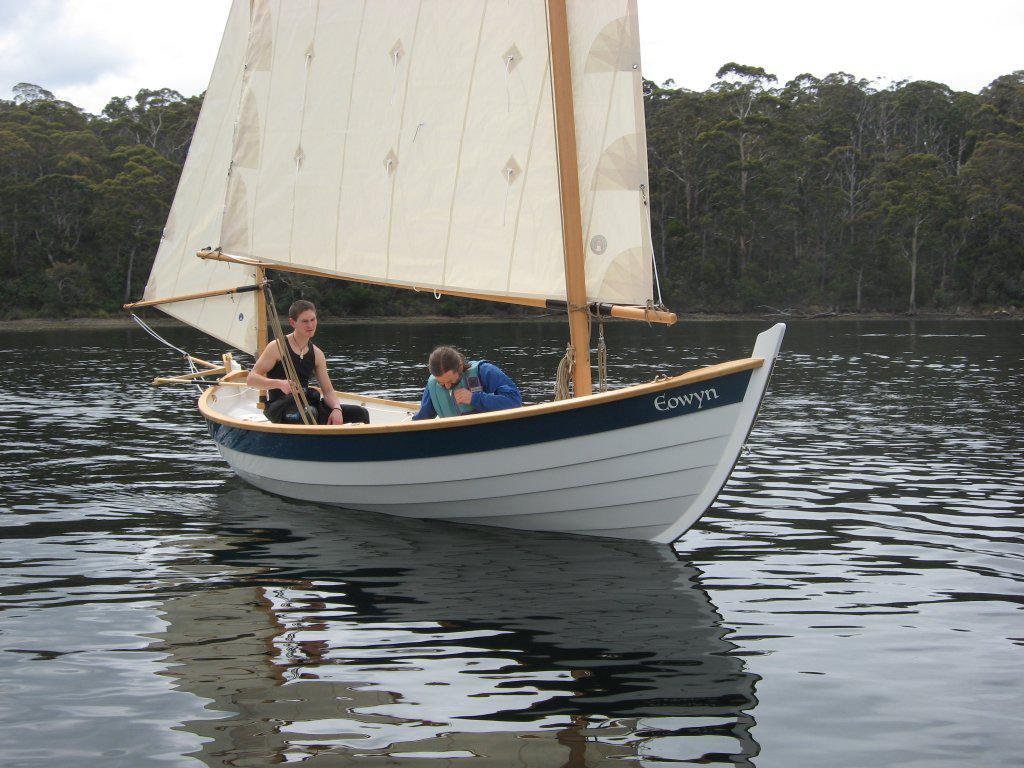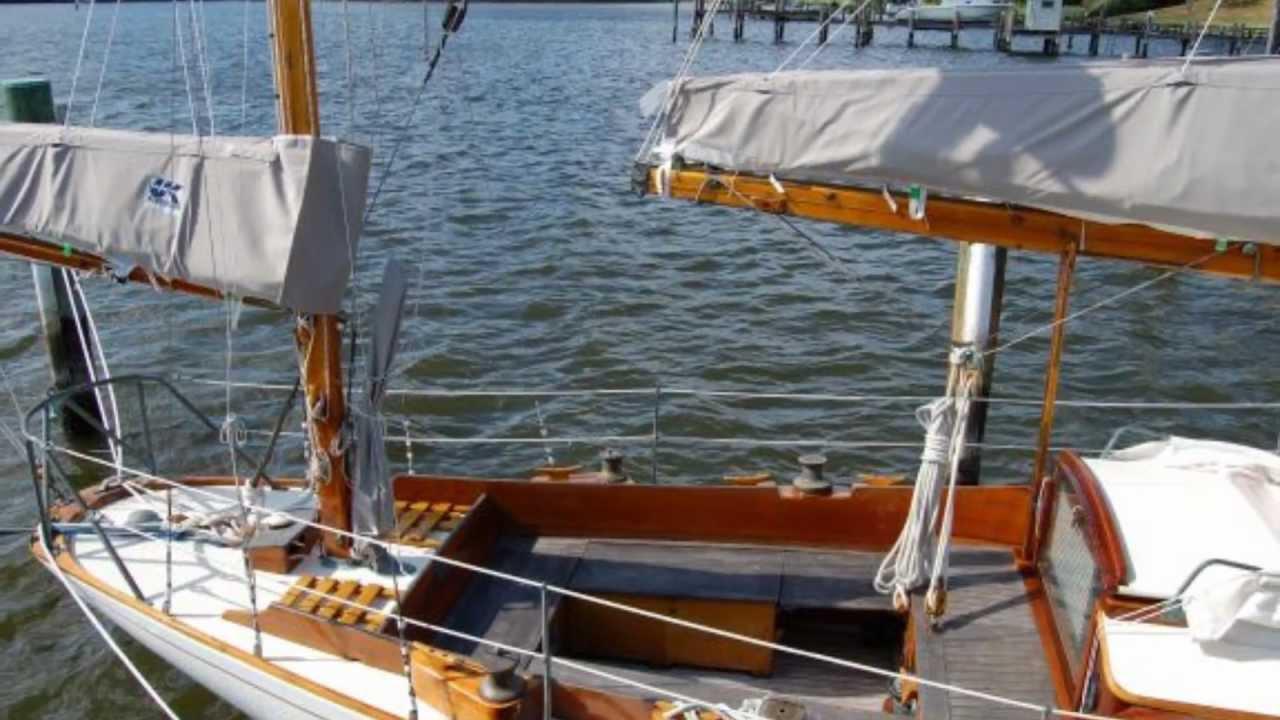The first image is the image on the left, the second image is the image on the right. Examine the images to the left and right. Is the description "Trees can be seen in the background of the image on the left." accurate? Answer yes or no. Yes. 